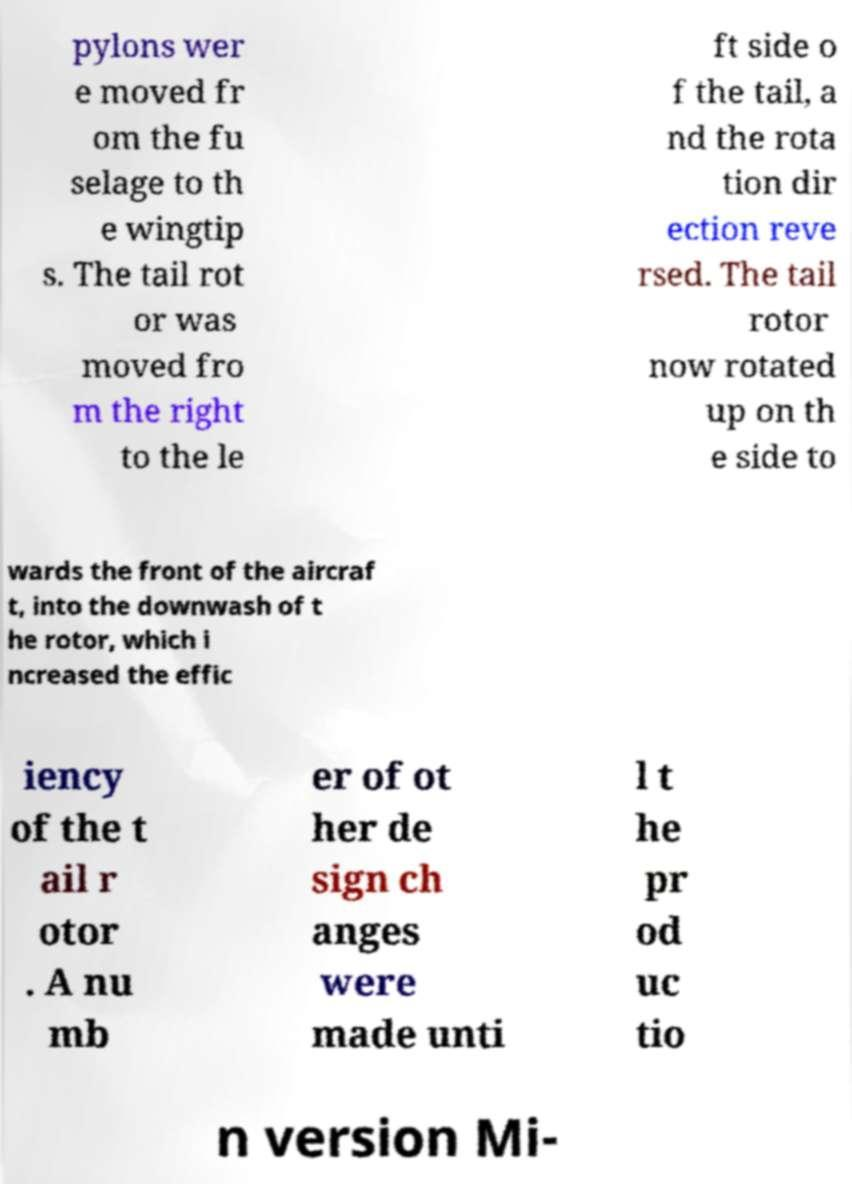Could you extract and type out the text from this image? pylons wer e moved fr om the fu selage to th e wingtip s. The tail rot or was moved fro m the right to the le ft side o f the tail, a nd the rota tion dir ection reve rsed. The tail rotor now rotated up on th e side to wards the front of the aircraf t, into the downwash of t he rotor, which i ncreased the effic iency of the t ail r otor . A nu mb er of ot her de sign ch anges were made unti l t he pr od uc tio n version Mi- 